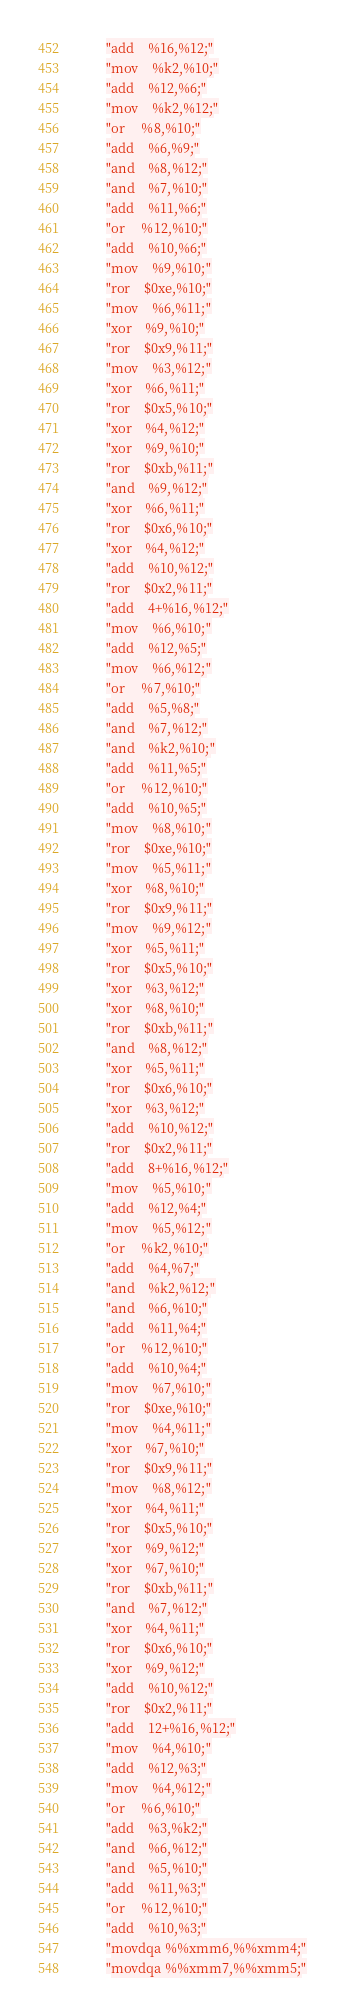<code> <loc_0><loc_0><loc_500><loc_500><_C++_>        "add    %16,%12;"
        "mov    %k2,%10;"
        "add    %12,%6;"
        "mov    %k2,%12;"
        "or     %8,%10;"
        "add    %6,%9;"
        "and    %8,%12;"
        "and    %7,%10;"
        "add    %11,%6;"
        "or     %12,%10;"
        "add    %10,%6;"
        "mov    %9,%10;"
        "ror    $0xe,%10;"
        "mov    %6,%11;"
        "xor    %9,%10;"
        "ror    $0x9,%11;"
        "mov    %3,%12;"
        "xor    %6,%11;"
        "ror    $0x5,%10;"
        "xor    %4,%12;"
        "xor    %9,%10;"
        "ror    $0xb,%11;"
        "and    %9,%12;"
        "xor    %6,%11;"
        "ror    $0x6,%10;"
        "xor    %4,%12;"
        "add    %10,%12;"
        "ror    $0x2,%11;"
        "add    4+%16,%12;"
        "mov    %6,%10;"
        "add    %12,%5;"
        "mov    %6,%12;"
        "or     %7,%10;"
        "add    %5,%8;"
        "and    %7,%12;"
        "and    %k2,%10;"
        "add    %11,%5;"
        "or     %12,%10;"
        "add    %10,%5;"
        "mov    %8,%10;"
        "ror    $0xe,%10;"
        "mov    %5,%11;"
        "xor    %8,%10;"
        "ror    $0x9,%11;"
        "mov    %9,%12;"
        "xor    %5,%11;"
        "ror    $0x5,%10;"
        "xor    %3,%12;"
        "xor    %8,%10;"
        "ror    $0xb,%11;"
        "and    %8,%12;"
        "xor    %5,%11;"
        "ror    $0x6,%10;"
        "xor    %3,%12;"
        "add    %10,%12;"
        "ror    $0x2,%11;"
        "add    8+%16,%12;"
        "mov    %5,%10;"
        "add    %12,%4;"
        "mov    %5,%12;"
        "or     %k2,%10;"
        "add    %4,%7;"
        "and    %k2,%12;"
        "and    %6,%10;"
        "add    %11,%4;"
        "or     %12,%10;"
        "add    %10,%4;"
        "mov    %7,%10;"
        "ror    $0xe,%10;"
        "mov    %4,%11;"
        "xor    %7,%10;"
        "ror    $0x9,%11;"
        "mov    %8,%12;"
        "xor    %4,%11;"
        "ror    $0x5,%10;"
        "xor    %9,%12;"
        "xor    %7,%10;"
        "ror    $0xb,%11;"
        "and    %7,%12;"
        "xor    %4,%11;"
        "ror    $0x6,%10;"
        "xor    %9,%12;"
        "add    %10,%12;"
        "ror    $0x2,%11;"
        "add    12+%16,%12;"
        "mov    %4,%10;"
        "add    %12,%3;"
        "mov    %4,%12;"
        "or     %6,%10;"
        "add    %3,%k2;"
        "and    %6,%12;"
        "and    %5,%10;"
        "add    %11,%3;"
        "or     %12,%10;"
        "add    %10,%3;"
        "movdqa %%xmm6,%%xmm4;"
        "movdqa %%xmm7,%%xmm5;"</code> 